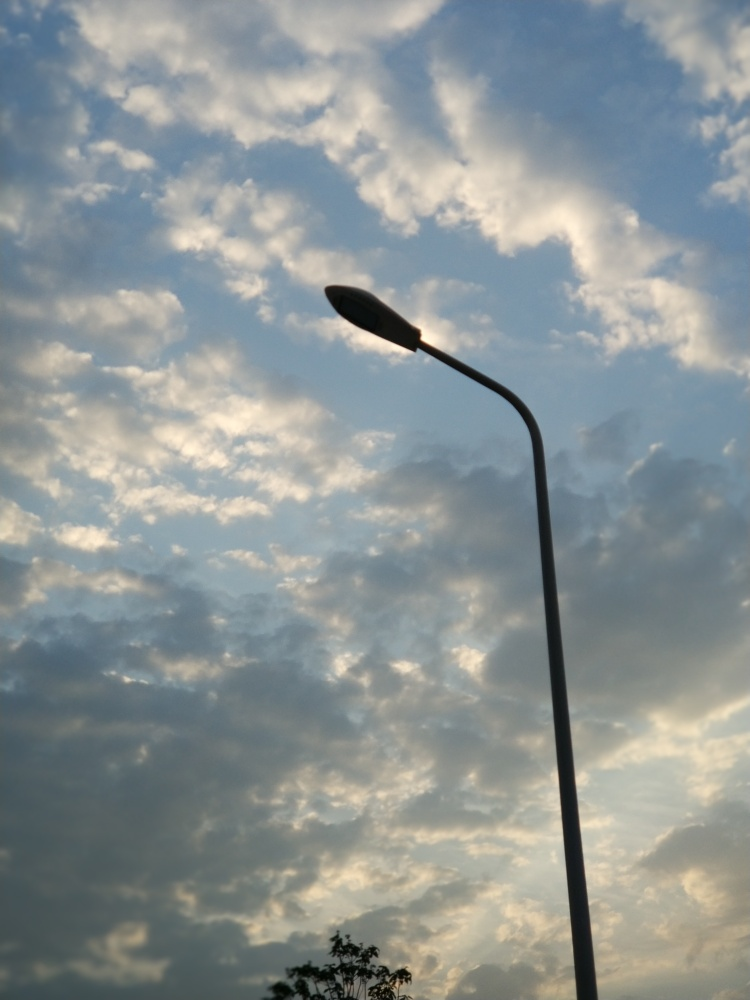How does the composition of this image influence its aesthetic appeal? The street lamp's vertical line draws the eye upward, creating a strong contrast with the horizontal layers of clouds, further emphasizing the vastness of the sky. This simple yet powerful composition provides a sense of balance and harmony, enhancing the image's overall aesthetic appeal. 